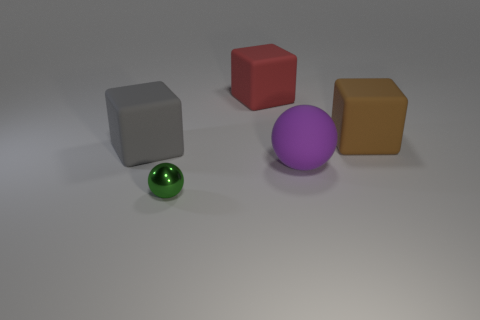There is a rubber object that is the same shape as the tiny green shiny thing; what is its color?
Provide a succinct answer. Purple. There is a ball that is the same material as the gray object; what is its color?
Your response must be concise. Purple. There is a big rubber thing in front of the block that is in front of the brown rubber cube; is there a large red block to the left of it?
Your answer should be compact. Yes. Is the number of big spheres in front of the green shiny thing less than the number of metallic spheres that are behind the rubber ball?
Your answer should be very brief. No. How many gray things are made of the same material as the big purple thing?
Your answer should be very brief. 1. There is a red block; is its size the same as the metallic thing that is in front of the red block?
Give a very brief answer. No. What size is the matte block that is on the right side of the rubber object in front of the big block that is to the left of the big red object?
Provide a succinct answer. Large. Is the number of large rubber balls behind the tiny green object greater than the number of gray things that are on the right side of the gray rubber cube?
Offer a very short reply. Yes. There is a large rubber block that is on the right side of the purple ball; how many small green spheres are left of it?
Provide a succinct answer. 1. Is the brown cube the same size as the green thing?
Your answer should be compact. No. 